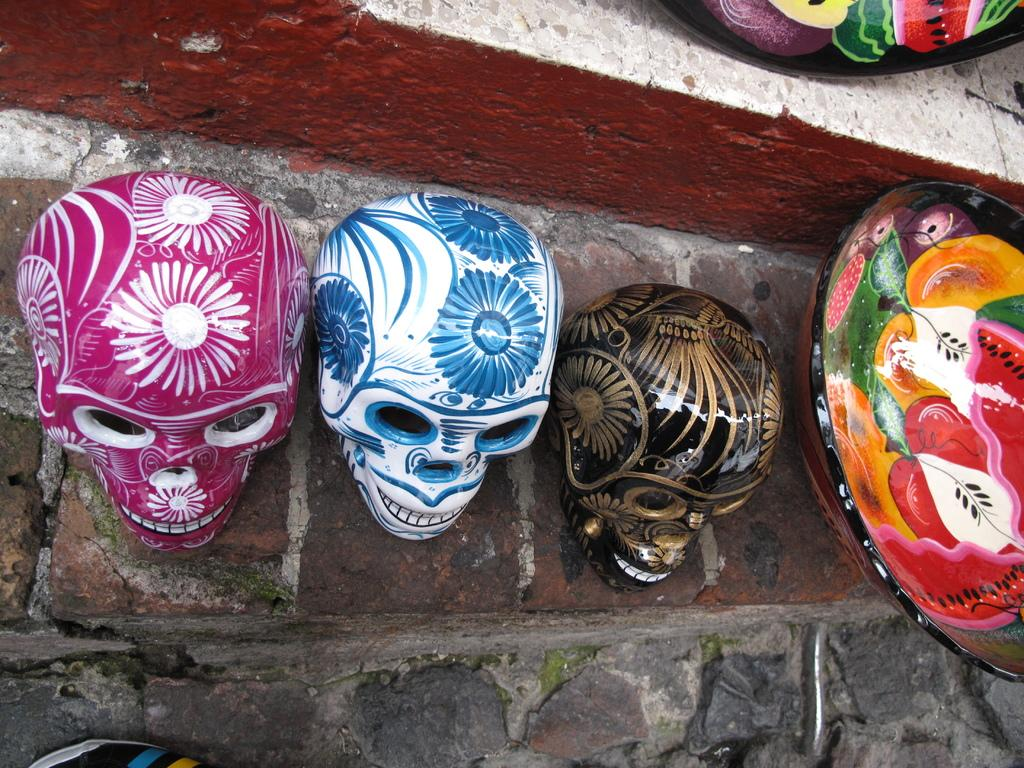How many skulls are present in the image? There are three skulls in the image. What is unique about the appearance of the skulls? The skulls are painted with different arts. What else can be seen in the image besides the skulls? There is a bowl with painting in the image. Where are the skulls placed in the image? The skulls are placed on a step. What direction is the lumber facing in the image? There is no lumber present in the image. How is the knife being used in the image? There is no knife present in the image. 